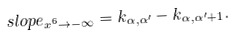<formula> <loc_0><loc_0><loc_500><loc_500>s l o p e _ { x ^ { 6 } \rightarrow - \infty } = k _ { \alpha , \alpha ^ { \prime } } - k _ { \alpha , \alpha ^ { \prime } + 1 } .</formula> 